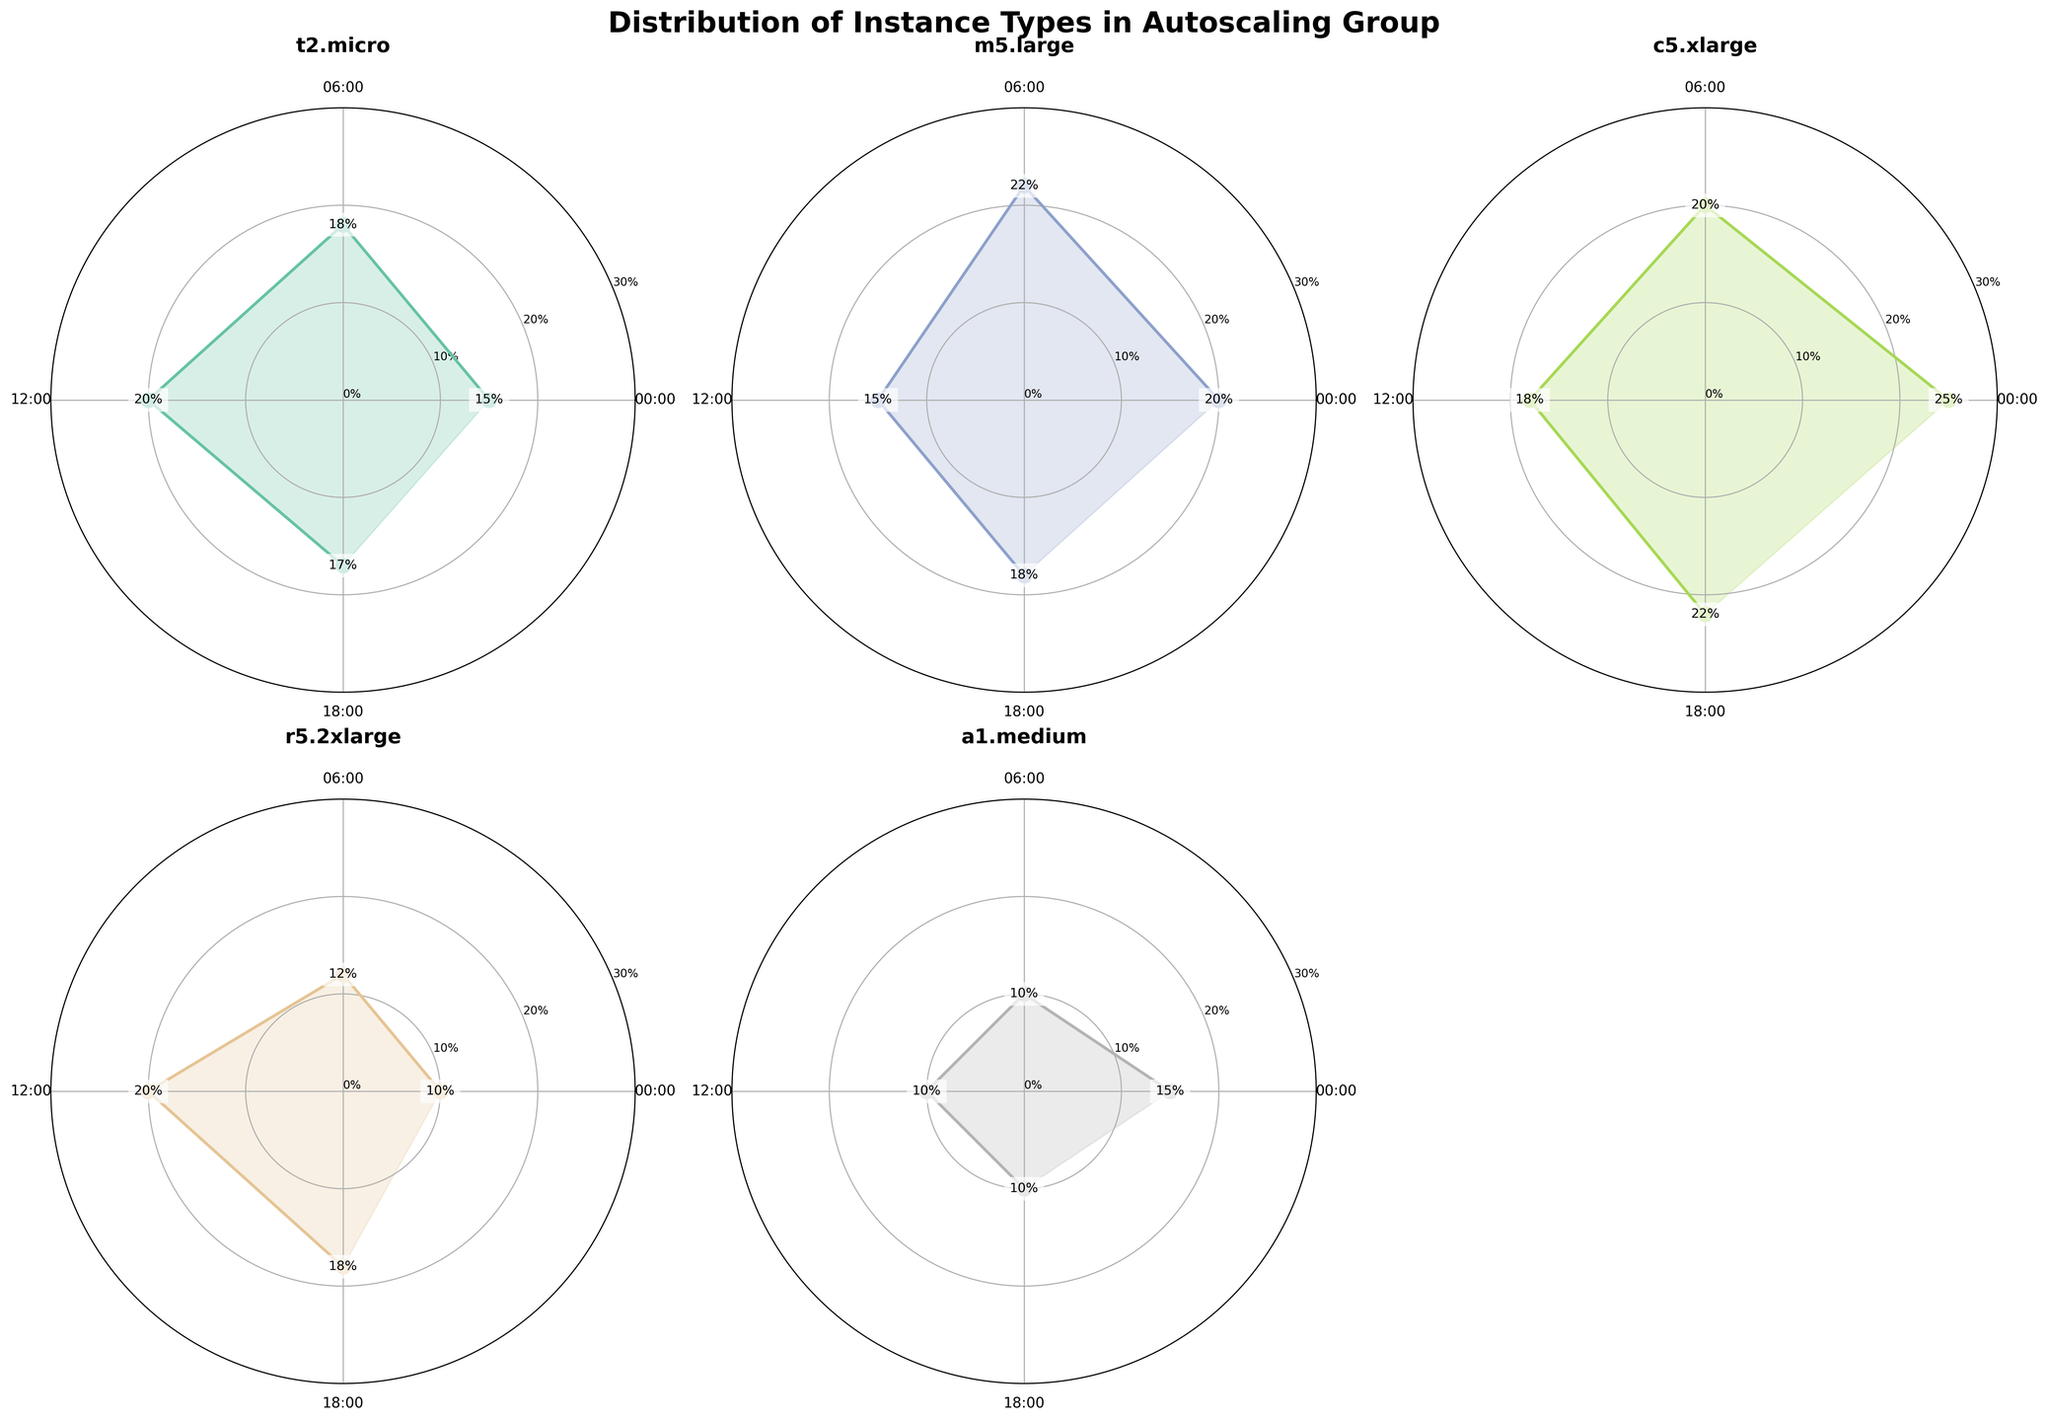What's the title of the plot? The title of the plot is displayed at the top center of the figure in bold font. It reads 'Distribution of Instance Types in Autoscaling Group'.
Answer: Distribution of Instance Types in Autoscaling Group Which instance type shows the highest percentage at 18:00? By examining the subplot for each instance type at the 18:00 time mark, the c5.xlarge instance type has the highest value at 22%.
Answer: c5.xlarge How many different instance types are shown in the figure? Each subplot represents a different instance type. In total, there are six subplots, representing six different instance types.
Answer: 6 What are the labels on the x-axis of the plots? The x-axis ticks, represented in radians for each plot, are labeled 00:00, 06:00, 12:00, and 18:00 to indicate different time intervals.
Answer: 00:00, 06:00, 12:00, 18:00 Which instance type has the most consistent percentage value across all times? Observing each polar chart, the a1.medium instance type has values of 15%, 10%, 10%, and 10%, showing the least variation across time intervals.
Answer: a1.medium Which instance type has the highest peak percentage value overall and what is that value? By finding the maximum percentage value in each subplot, the c5.xlarge instance type reaches the highest peak percentage value of 25% at 00:00.
Answer: c5.xlarge, 25% Rank the instance types from highest to lowest peak percentage value. The peak values from each subplot are: c5.xlarge (25%), m5.large (22%), t2.micro (20%), r5.2xlarge (20%), a1.medium (15%). Therefore, the ranking is: c5.xlarge, m5.large, t2.micro and r5.2xlarge (tie), a1.medium.
Answer: c5.xlarge > m5.large > t2.micro = r5.2xlarge > a1.medium Which instance type shows the largest increase in percentage from 00:00 to 12:00? Comparing the values for 00:00 and 12:00 in each subplot, r5.2xlarge increases from 10% to 20%, a jump of 10 percentage points, the largest among the instance types.
Answer: r5.2xlarge What is the average percentage for instance type t2.micro across all time intervals? The percentages for t2.micro are 15%, 18%, 20%, and 17%. Summing these, 15 + 18 + 20 + 17 = 70, and dividing by 4 time intervals gives 70/4 = 17.5%.
Answer: 17.5% How does the percentage for m5.large at 12:00 compare to its percentage at 06:00? Observing the m5.large subplot, it has percentages of 15% at 12:00 and 22% at 06:00. The value at 12:00 is 7 percentage points lower than at 06:00.
Answer: 7 percentage points lower 